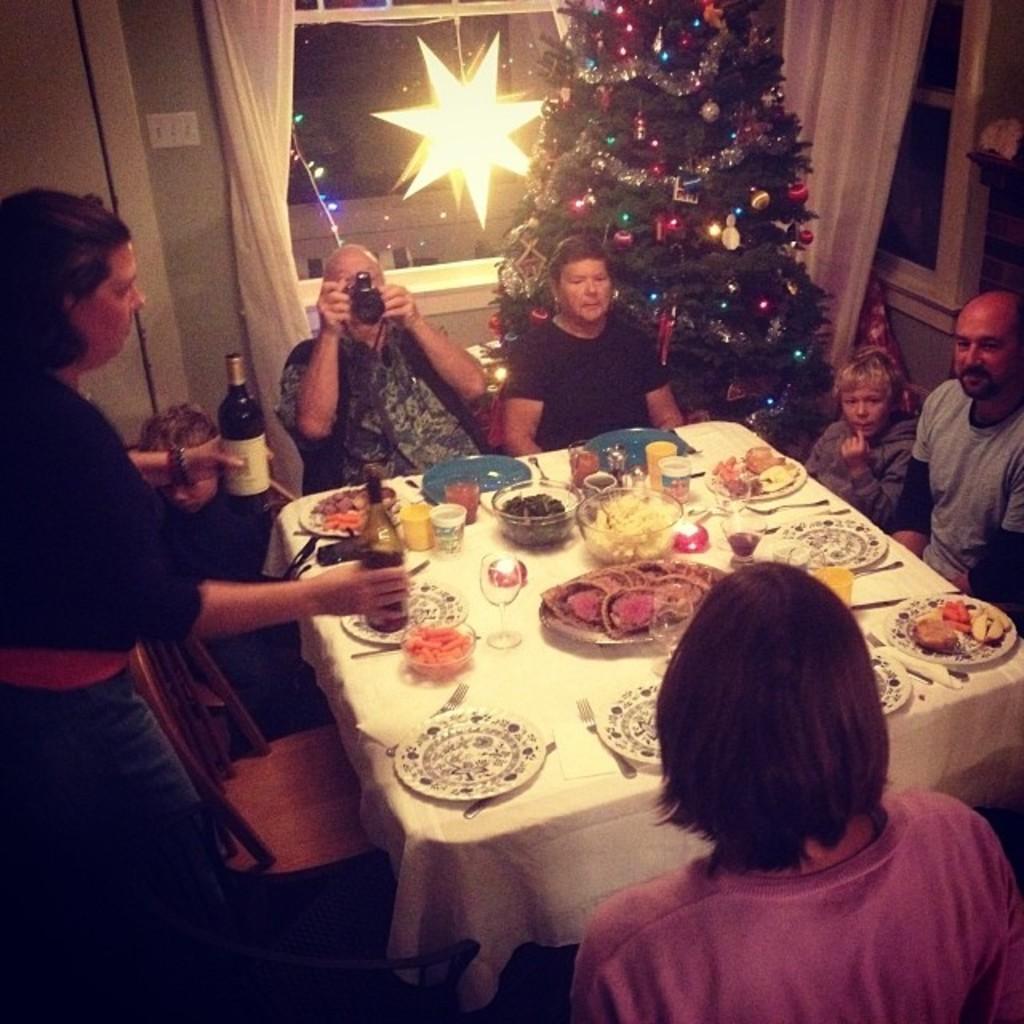Describe this image in one or two sentences. Here, we can see a table which is covered by a white color cloth, there are some plates and there are some glasses on the table, there are some people sitting on the chairs around the table, at the left side there is a woman, she is standing and she is holding wine bottles, at the background there is x-mass tree, there is a window and there is a white color curtain. 